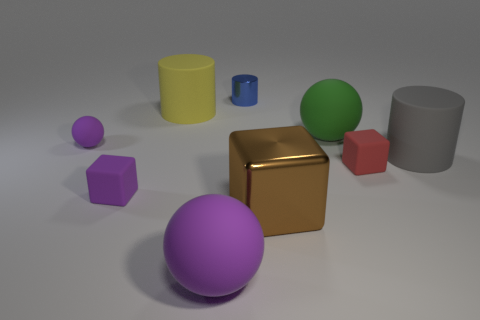There is a big rubber object in front of the brown shiny thing; does it have the same color as the tiny sphere?
Make the answer very short. Yes. Are there any other things that have the same color as the small matte ball?
Your answer should be compact. Yes. What shape is the tiny matte thing that is the same color as the tiny sphere?
Give a very brief answer. Cube. Are there any purple rubber spheres?
Offer a very short reply. Yes. There is a matte cylinder in front of the green object; is its size the same as the purple ball in front of the large gray matte cylinder?
Give a very brief answer. Yes. What material is the sphere that is both in front of the big green sphere and behind the large brown metal object?
Your response must be concise. Rubber. What number of big green spheres are behind the yellow object?
Make the answer very short. 0. Is there any other thing that has the same size as the red thing?
Offer a very short reply. Yes. What is the color of the large cube that is made of the same material as the tiny blue cylinder?
Offer a very short reply. Brown. Is the brown metallic object the same shape as the small blue metallic object?
Offer a terse response. No. 